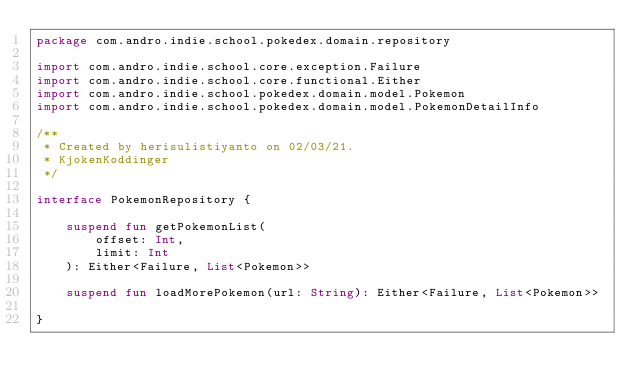Convert code to text. <code><loc_0><loc_0><loc_500><loc_500><_Kotlin_>package com.andro.indie.school.pokedex.domain.repository

import com.andro.indie.school.core.exception.Failure
import com.andro.indie.school.core.functional.Either
import com.andro.indie.school.pokedex.domain.model.Pokemon
import com.andro.indie.school.pokedex.domain.model.PokemonDetailInfo

/**
 * Created by herisulistiyanto on 02/03/21.
 * KjokenKoddinger
 */

interface PokemonRepository {

    suspend fun getPokemonList(
        offset: Int,
        limit: Int
    ): Either<Failure, List<Pokemon>>

    suspend fun loadMorePokemon(url: String): Either<Failure, List<Pokemon>>

}</code> 